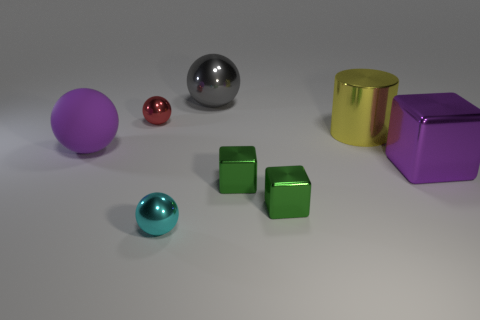Subtract all brown balls. Subtract all red cylinders. How many balls are left? 4 Add 1 tiny brown cylinders. How many objects exist? 9 Subtract all cubes. How many objects are left? 5 Subtract all gray metallic objects. Subtract all red shiny objects. How many objects are left? 6 Add 3 big blocks. How many big blocks are left? 4 Add 3 red rubber cylinders. How many red rubber cylinders exist? 3 Subtract 0 red blocks. How many objects are left? 8 